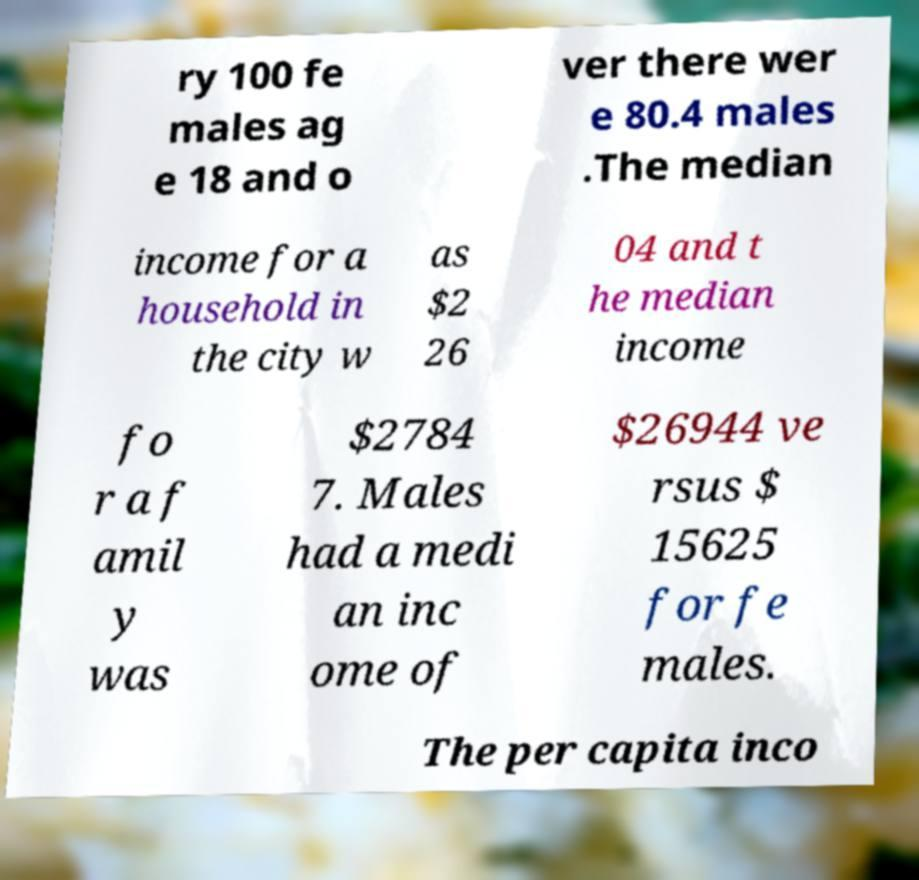For documentation purposes, I need the text within this image transcribed. Could you provide that? ry 100 fe males ag e 18 and o ver there wer e 80.4 males .The median income for a household in the city w as $2 26 04 and t he median income fo r a f amil y was $2784 7. Males had a medi an inc ome of $26944 ve rsus $ 15625 for fe males. The per capita inco 